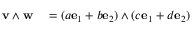Convert formula to latex. <formula><loc_0><loc_0><loc_500><loc_500>\begin{array} { r l } { { v } \wedge { w } } & = ( a { e } _ { 1 } + b { e } _ { 2 } ) \wedge ( c { e } _ { 1 } + d { e } _ { 2 } ) } \end{array}</formula> 